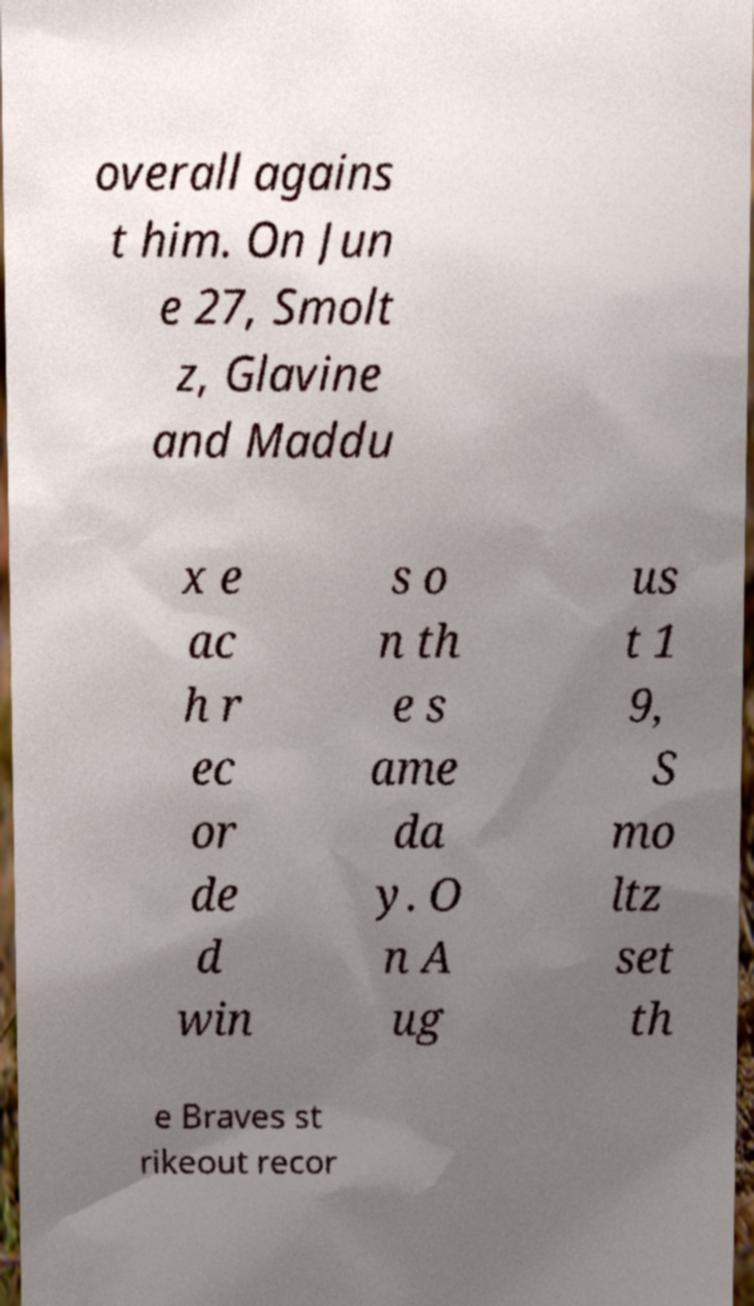I need the written content from this picture converted into text. Can you do that? overall agains t him. On Jun e 27, Smolt z, Glavine and Maddu x e ac h r ec or de d win s o n th e s ame da y. O n A ug us t 1 9, S mo ltz set th e Braves st rikeout recor 